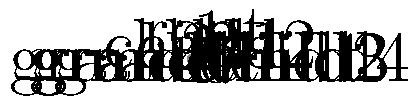Given the following DOM manipulation code snippet:

```java
Document doc = builder.parse(inputStream);
Element root = doc.getDocumentElement();
NodeList children = root.getChildNodes();
Element child2 = (Element) children.item(1);
child2.removeChild(child2.getLastChild());
```

Which node in the XML tree structure shown above will be removed after executing this code? Let's analyze the code step-by-step:

1. The document is parsed and the root element is obtained.
2. We get the list of child nodes of the root element.
3. We select the second child (index 1) of the root and cast it to an Element. This corresponds to "child2" in our tree.
4. We then remove the last child of "child2".

In the given tree structure:
- Node 1 is the root
- Nodes 2 and 3 are the children of the root (child1 and child2 respectively)
- Nodes 4 and 5 are children of child1
- Nodes 6 and 7 are children of child2

The code is removing the last child of child2 (node 3). The last child of child2 is node 7, labeled as "grandchild4" in the tree.

Therefore, node 7 (grandchild4) will be removed from the tree after executing this code.
Answer: Node 7 (grandchild4) 